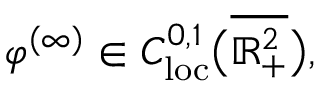<formula> <loc_0><loc_0><loc_500><loc_500>\varphi ^ { ( \infty ) } \in C _ { l o c } ^ { 0 , 1 } \left ( \overline { { \mathbb { R } _ { + } ^ { 2 } } } \right ) ,</formula> 